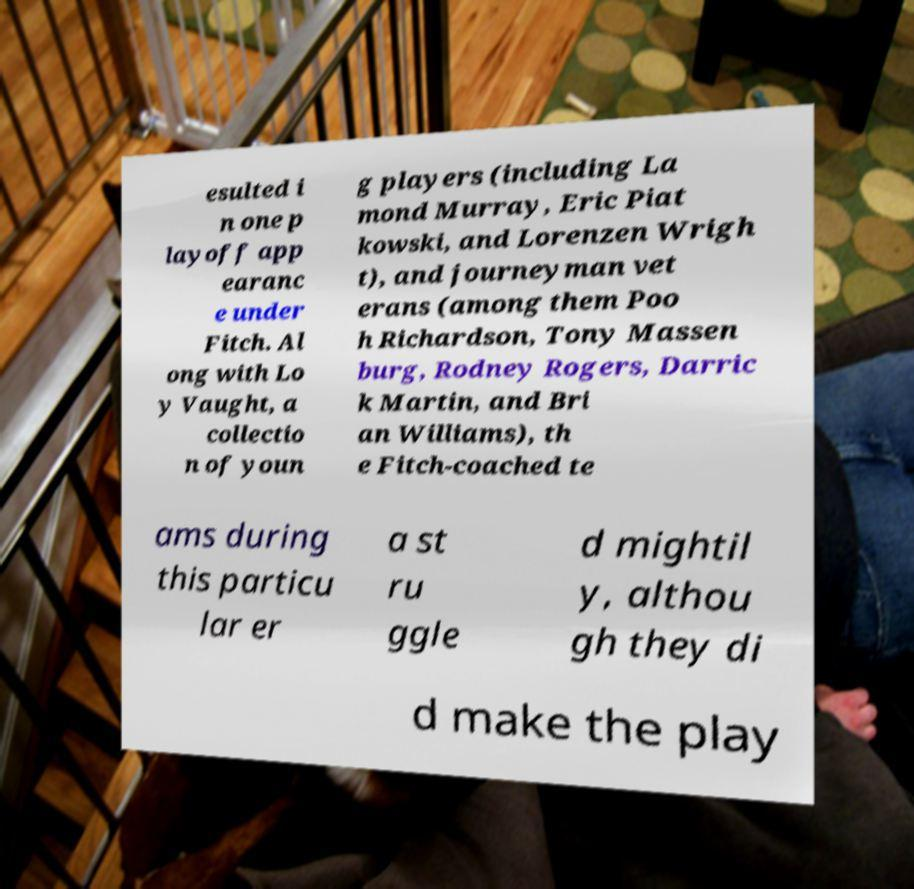I need the written content from this picture converted into text. Can you do that? esulted i n one p layoff app earanc e under Fitch. Al ong with Lo y Vaught, a collectio n of youn g players (including La mond Murray, Eric Piat kowski, and Lorenzen Wrigh t), and journeyman vet erans (among them Poo h Richardson, Tony Massen burg, Rodney Rogers, Darric k Martin, and Bri an Williams), th e Fitch-coached te ams during this particu lar er a st ru ggle d mightil y, althou gh they di d make the play 